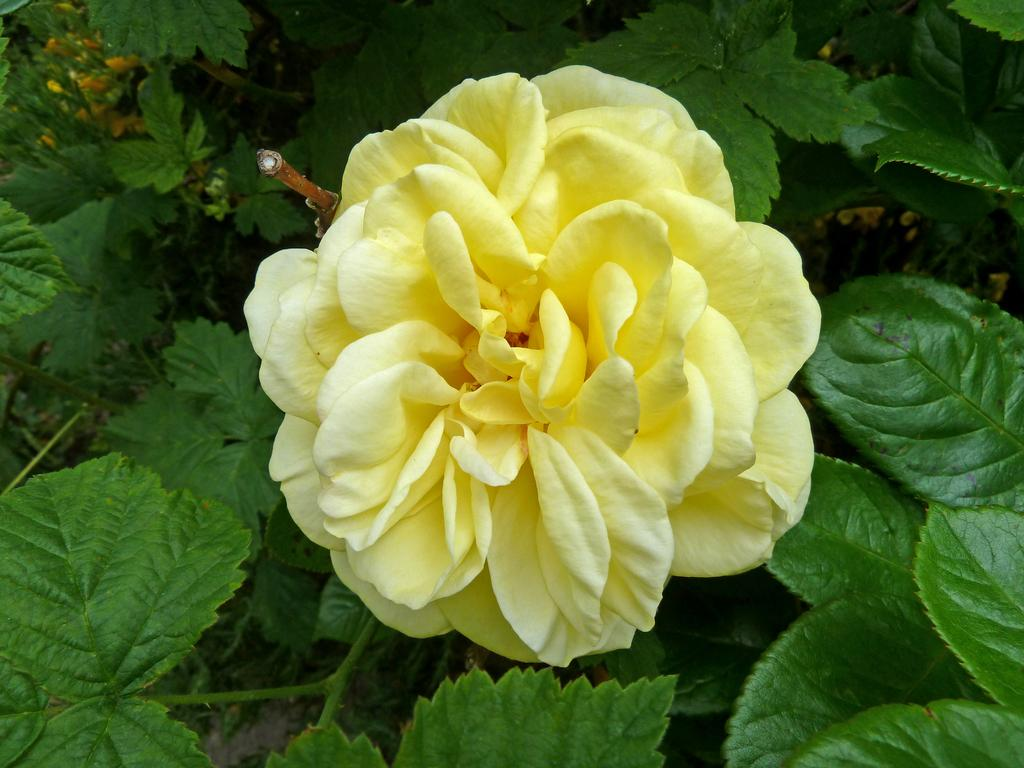What is the main subject of the image? There is a yellow rose in the center of the image. What can be seen surrounding the yellow rose? There are leaves around the area of the image. What type of doctor is examining the guitar in the image? There is no doctor or guitar present in the image; it features a yellow rose and leaves. 